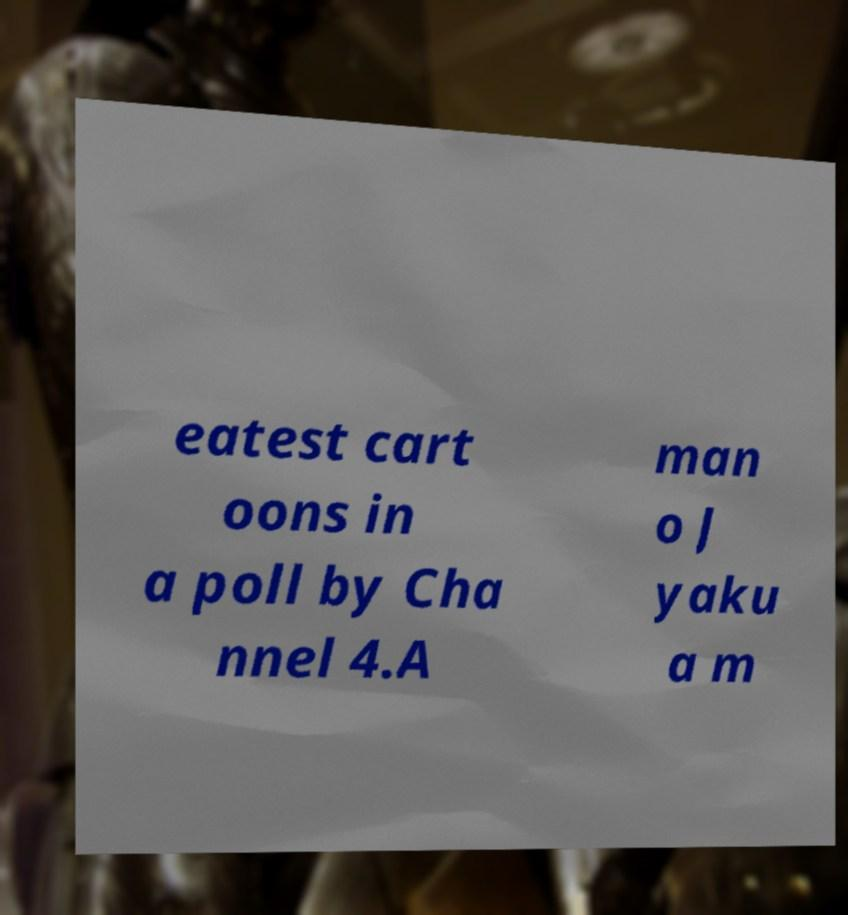Can you accurately transcribe the text from the provided image for me? eatest cart oons in a poll by Cha nnel 4.A man o J yaku a m 